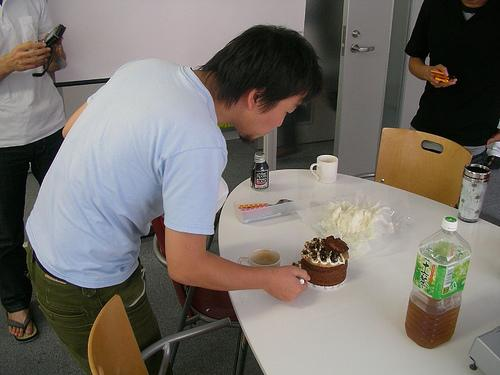About how much liquid is in the bottle with the green label? Please explain your reasoning. third. A third of the tea bottle is filled with fluid. 